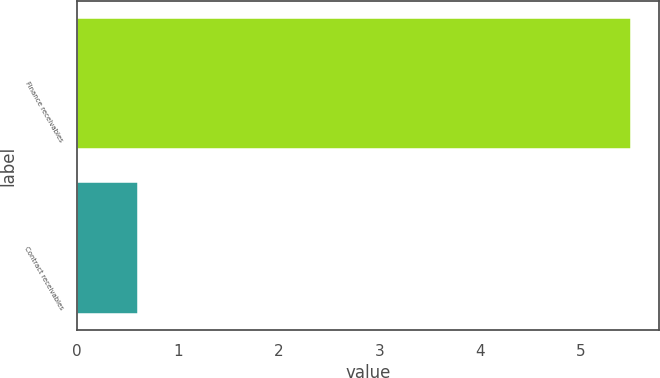Convert chart. <chart><loc_0><loc_0><loc_500><loc_500><bar_chart><fcel>Finance receivables<fcel>Contract receivables<nl><fcel>5.5<fcel>0.6<nl></chart> 